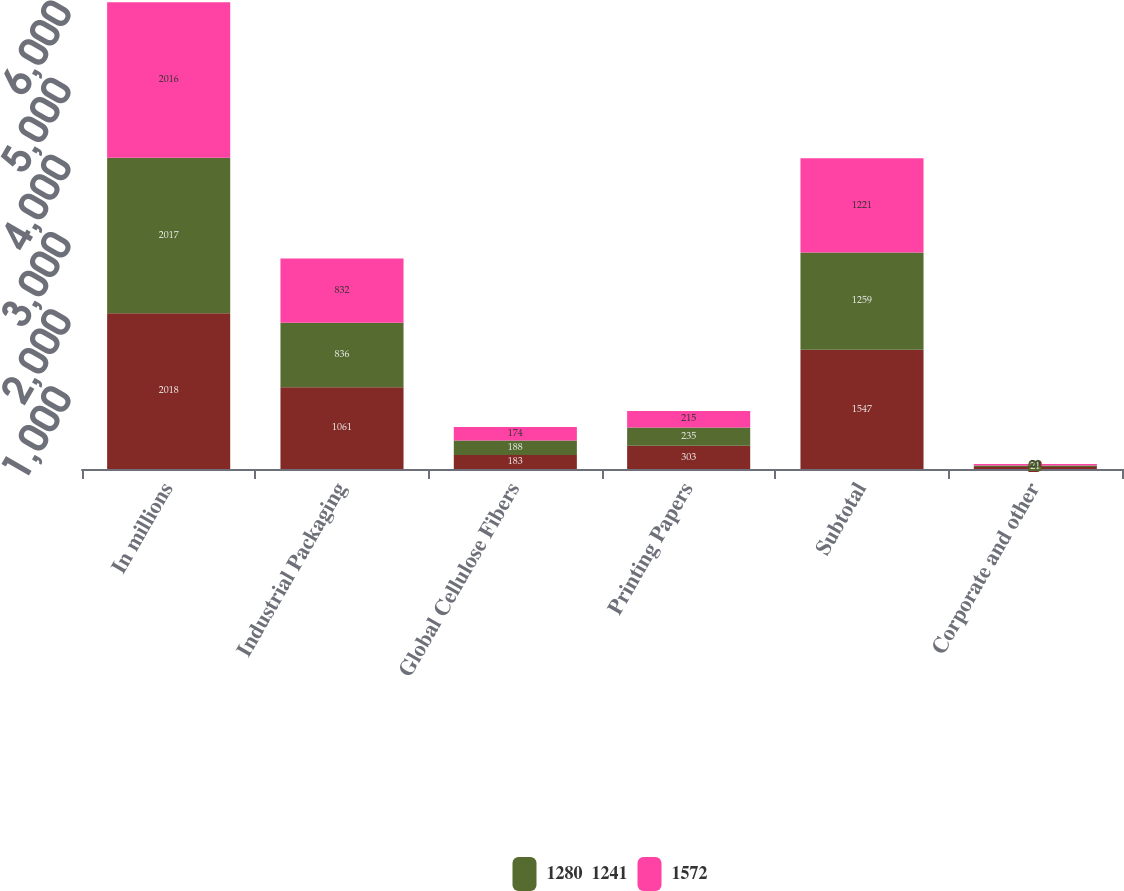Convert chart to OTSL. <chart><loc_0><loc_0><loc_500><loc_500><stacked_bar_chart><ecel><fcel>In millions<fcel>Industrial Packaging<fcel>Global Cellulose Fibers<fcel>Printing Papers<fcel>Subtotal<fcel>Corporate and other<nl><fcel>nan<fcel>2018<fcel>1061<fcel>183<fcel>303<fcel>1547<fcel>25<nl><fcel>1280  1241<fcel>2017<fcel>836<fcel>188<fcel>235<fcel>1259<fcel>21<nl><fcel>1572<fcel>2016<fcel>832<fcel>174<fcel>215<fcel>1221<fcel>20<nl></chart> 